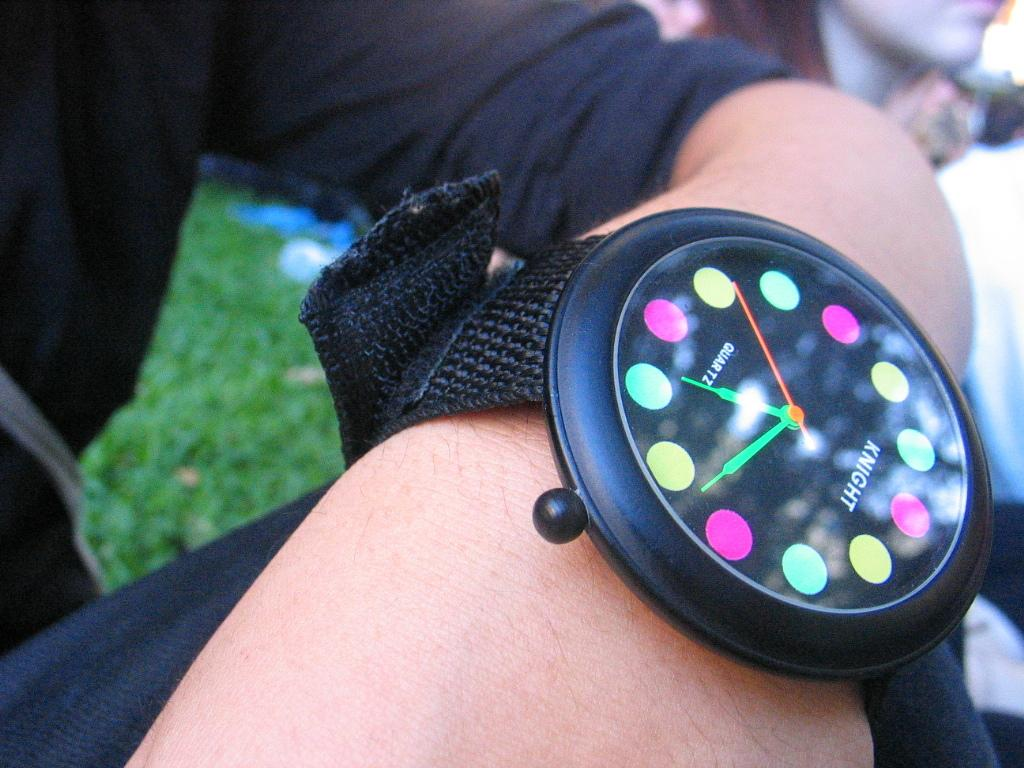<image>
Relay a brief, clear account of the picture shown. Someone is wearing a knight watch that has colored dots in place of the numbers. 